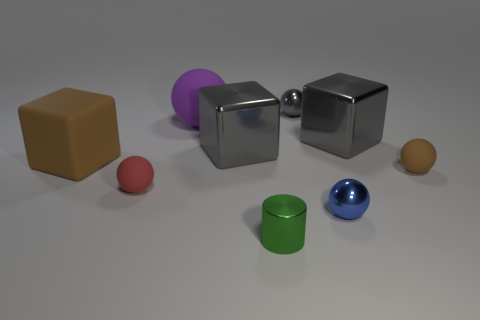What could be the material of the shiny objects? The shiny objects appear to have a reflective surface that could be indicative of materials like polished metal or glossy plastic. 